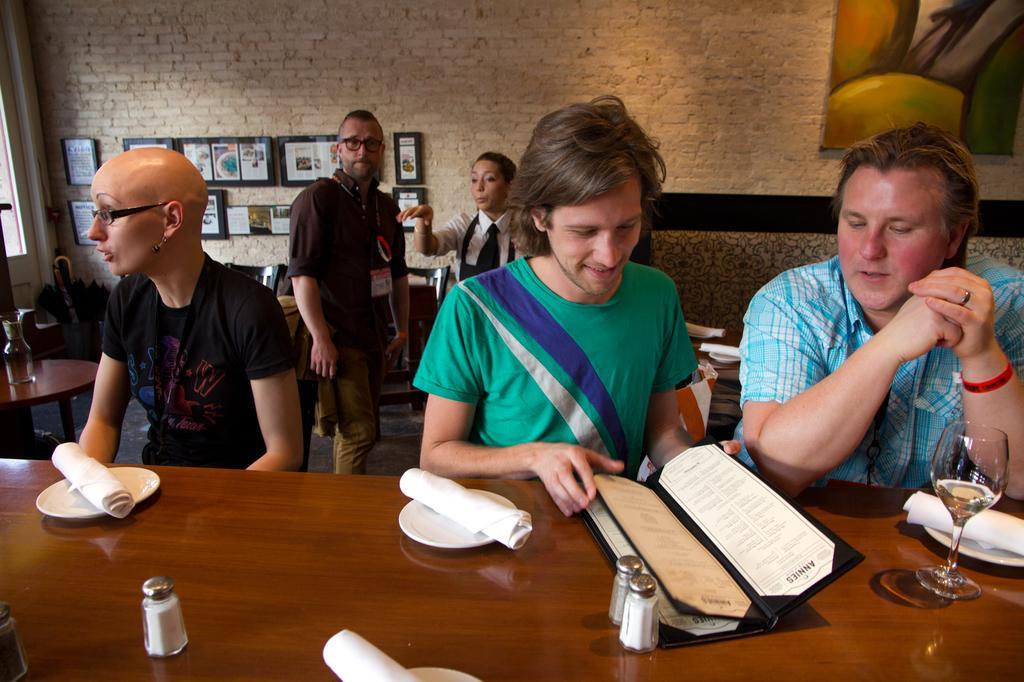Could you give a brief overview of what you see in this image? In this picture we can see three people in front of table, in the background there are two people standing, the person second from the right side of the image is looking at menu, we can see one glass of drink and three plates and three clothes on the table and in the background we can see a brick wall and some photo frames, on the right side of the image we can see a portrait. 